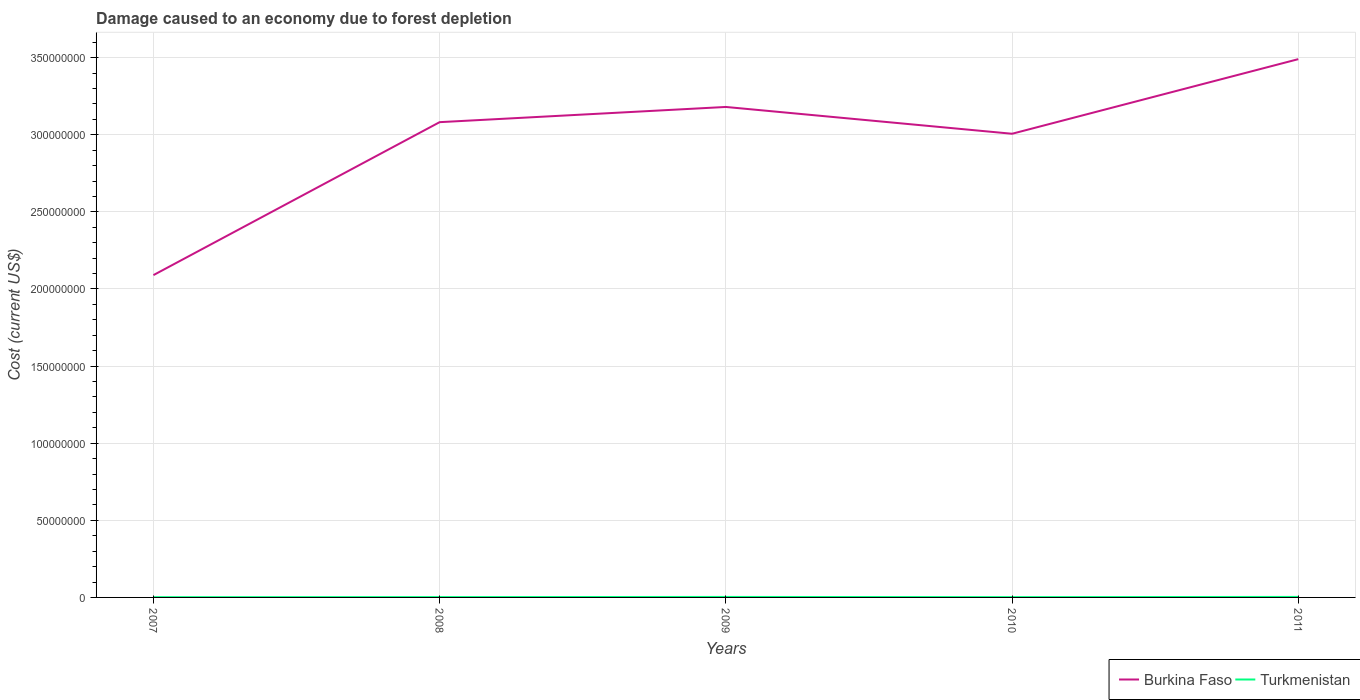Across all years, what is the maximum cost of damage caused due to forest depletion in Burkina Faso?
Your response must be concise. 2.09e+08. What is the total cost of damage caused due to forest depletion in Turkmenistan in the graph?
Offer a very short reply. -1.35e+05. What is the difference between the highest and the second highest cost of damage caused due to forest depletion in Turkmenistan?
Provide a succinct answer. 1.66e+05. What is the difference between the highest and the lowest cost of damage caused due to forest depletion in Burkina Faso?
Give a very brief answer. 4. Is the cost of damage caused due to forest depletion in Turkmenistan strictly greater than the cost of damage caused due to forest depletion in Burkina Faso over the years?
Offer a terse response. Yes. How many lines are there?
Keep it short and to the point. 2. What is the difference between two consecutive major ticks on the Y-axis?
Your response must be concise. 5.00e+07. Are the values on the major ticks of Y-axis written in scientific E-notation?
Keep it short and to the point. No. How many legend labels are there?
Offer a very short reply. 2. How are the legend labels stacked?
Keep it short and to the point. Horizontal. What is the title of the graph?
Provide a succinct answer. Damage caused to an economy due to forest depletion. Does "Cayman Islands" appear as one of the legend labels in the graph?
Offer a terse response. No. What is the label or title of the X-axis?
Your answer should be very brief. Years. What is the label or title of the Y-axis?
Ensure brevity in your answer.  Cost (current US$). What is the Cost (current US$) in Burkina Faso in 2007?
Your response must be concise. 2.09e+08. What is the Cost (current US$) of Turkmenistan in 2007?
Give a very brief answer. 1.61e+05. What is the Cost (current US$) in Burkina Faso in 2008?
Make the answer very short. 3.08e+08. What is the Cost (current US$) in Turkmenistan in 2008?
Make the answer very short. 2.20e+05. What is the Cost (current US$) in Burkina Faso in 2009?
Make the answer very short. 3.18e+08. What is the Cost (current US$) in Turkmenistan in 2009?
Ensure brevity in your answer.  3.14e+05. What is the Cost (current US$) in Burkina Faso in 2010?
Your answer should be compact. 3.01e+08. What is the Cost (current US$) in Turkmenistan in 2010?
Provide a short and direct response. 1.93e+05. What is the Cost (current US$) of Burkina Faso in 2011?
Your answer should be very brief. 3.49e+08. What is the Cost (current US$) of Turkmenistan in 2011?
Your answer should be compact. 3.28e+05. Across all years, what is the maximum Cost (current US$) of Burkina Faso?
Give a very brief answer. 3.49e+08. Across all years, what is the maximum Cost (current US$) of Turkmenistan?
Your response must be concise. 3.28e+05. Across all years, what is the minimum Cost (current US$) of Burkina Faso?
Keep it short and to the point. 2.09e+08. Across all years, what is the minimum Cost (current US$) in Turkmenistan?
Provide a short and direct response. 1.61e+05. What is the total Cost (current US$) in Burkina Faso in the graph?
Your answer should be compact. 1.48e+09. What is the total Cost (current US$) in Turkmenistan in the graph?
Give a very brief answer. 1.22e+06. What is the difference between the Cost (current US$) in Burkina Faso in 2007 and that in 2008?
Provide a succinct answer. -9.92e+07. What is the difference between the Cost (current US$) of Turkmenistan in 2007 and that in 2008?
Ensure brevity in your answer.  -5.89e+04. What is the difference between the Cost (current US$) of Burkina Faso in 2007 and that in 2009?
Your answer should be compact. -1.09e+08. What is the difference between the Cost (current US$) in Turkmenistan in 2007 and that in 2009?
Your answer should be very brief. -1.52e+05. What is the difference between the Cost (current US$) in Burkina Faso in 2007 and that in 2010?
Provide a succinct answer. -9.17e+07. What is the difference between the Cost (current US$) in Turkmenistan in 2007 and that in 2010?
Your answer should be very brief. -3.18e+04. What is the difference between the Cost (current US$) of Burkina Faso in 2007 and that in 2011?
Make the answer very short. -1.40e+08. What is the difference between the Cost (current US$) of Turkmenistan in 2007 and that in 2011?
Your answer should be compact. -1.66e+05. What is the difference between the Cost (current US$) in Burkina Faso in 2008 and that in 2009?
Give a very brief answer. -9.86e+06. What is the difference between the Cost (current US$) of Turkmenistan in 2008 and that in 2009?
Your response must be concise. -9.36e+04. What is the difference between the Cost (current US$) in Burkina Faso in 2008 and that in 2010?
Provide a succinct answer. 7.52e+06. What is the difference between the Cost (current US$) of Turkmenistan in 2008 and that in 2010?
Offer a very short reply. 2.71e+04. What is the difference between the Cost (current US$) in Burkina Faso in 2008 and that in 2011?
Provide a succinct answer. -4.09e+07. What is the difference between the Cost (current US$) in Turkmenistan in 2008 and that in 2011?
Make the answer very short. -1.07e+05. What is the difference between the Cost (current US$) in Burkina Faso in 2009 and that in 2010?
Offer a very short reply. 1.74e+07. What is the difference between the Cost (current US$) of Turkmenistan in 2009 and that in 2010?
Make the answer very short. 1.21e+05. What is the difference between the Cost (current US$) of Burkina Faso in 2009 and that in 2011?
Your response must be concise. -3.10e+07. What is the difference between the Cost (current US$) of Turkmenistan in 2009 and that in 2011?
Offer a terse response. -1.39e+04. What is the difference between the Cost (current US$) of Burkina Faso in 2010 and that in 2011?
Make the answer very short. -4.84e+07. What is the difference between the Cost (current US$) in Turkmenistan in 2010 and that in 2011?
Your answer should be compact. -1.35e+05. What is the difference between the Cost (current US$) in Burkina Faso in 2007 and the Cost (current US$) in Turkmenistan in 2008?
Give a very brief answer. 2.09e+08. What is the difference between the Cost (current US$) in Burkina Faso in 2007 and the Cost (current US$) in Turkmenistan in 2009?
Provide a short and direct response. 2.09e+08. What is the difference between the Cost (current US$) of Burkina Faso in 2007 and the Cost (current US$) of Turkmenistan in 2010?
Provide a short and direct response. 2.09e+08. What is the difference between the Cost (current US$) of Burkina Faso in 2007 and the Cost (current US$) of Turkmenistan in 2011?
Give a very brief answer. 2.09e+08. What is the difference between the Cost (current US$) of Burkina Faso in 2008 and the Cost (current US$) of Turkmenistan in 2009?
Keep it short and to the point. 3.08e+08. What is the difference between the Cost (current US$) in Burkina Faso in 2008 and the Cost (current US$) in Turkmenistan in 2010?
Ensure brevity in your answer.  3.08e+08. What is the difference between the Cost (current US$) in Burkina Faso in 2008 and the Cost (current US$) in Turkmenistan in 2011?
Keep it short and to the point. 3.08e+08. What is the difference between the Cost (current US$) of Burkina Faso in 2009 and the Cost (current US$) of Turkmenistan in 2010?
Make the answer very short. 3.18e+08. What is the difference between the Cost (current US$) of Burkina Faso in 2009 and the Cost (current US$) of Turkmenistan in 2011?
Make the answer very short. 3.18e+08. What is the difference between the Cost (current US$) in Burkina Faso in 2010 and the Cost (current US$) in Turkmenistan in 2011?
Offer a very short reply. 3.00e+08. What is the average Cost (current US$) in Burkina Faso per year?
Your answer should be compact. 2.97e+08. What is the average Cost (current US$) of Turkmenistan per year?
Give a very brief answer. 2.43e+05. In the year 2007, what is the difference between the Cost (current US$) of Burkina Faso and Cost (current US$) of Turkmenistan?
Your answer should be compact. 2.09e+08. In the year 2008, what is the difference between the Cost (current US$) of Burkina Faso and Cost (current US$) of Turkmenistan?
Your response must be concise. 3.08e+08. In the year 2009, what is the difference between the Cost (current US$) in Burkina Faso and Cost (current US$) in Turkmenistan?
Keep it short and to the point. 3.18e+08. In the year 2010, what is the difference between the Cost (current US$) of Burkina Faso and Cost (current US$) of Turkmenistan?
Provide a short and direct response. 3.00e+08. In the year 2011, what is the difference between the Cost (current US$) of Burkina Faso and Cost (current US$) of Turkmenistan?
Keep it short and to the point. 3.49e+08. What is the ratio of the Cost (current US$) in Burkina Faso in 2007 to that in 2008?
Give a very brief answer. 0.68. What is the ratio of the Cost (current US$) of Turkmenistan in 2007 to that in 2008?
Offer a very short reply. 0.73. What is the ratio of the Cost (current US$) of Burkina Faso in 2007 to that in 2009?
Keep it short and to the point. 0.66. What is the ratio of the Cost (current US$) of Turkmenistan in 2007 to that in 2009?
Give a very brief answer. 0.51. What is the ratio of the Cost (current US$) in Burkina Faso in 2007 to that in 2010?
Your answer should be compact. 0.7. What is the ratio of the Cost (current US$) in Turkmenistan in 2007 to that in 2010?
Your answer should be very brief. 0.84. What is the ratio of the Cost (current US$) of Burkina Faso in 2007 to that in 2011?
Your answer should be compact. 0.6. What is the ratio of the Cost (current US$) in Turkmenistan in 2007 to that in 2011?
Give a very brief answer. 0.49. What is the ratio of the Cost (current US$) in Turkmenistan in 2008 to that in 2009?
Provide a short and direct response. 0.7. What is the ratio of the Cost (current US$) of Burkina Faso in 2008 to that in 2010?
Offer a very short reply. 1.02. What is the ratio of the Cost (current US$) of Turkmenistan in 2008 to that in 2010?
Give a very brief answer. 1.14. What is the ratio of the Cost (current US$) in Burkina Faso in 2008 to that in 2011?
Give a very brief answer. 0.88. What is the ratio of the Cost (current US$) of Turkmenistan in 2008 to that in 2011?
Give a very brief answer. 0.67. What is the ratio of the Cost (current US$) of Burkina Faso in 2009 to that in 2010?
Keep it short and to the point. 1.06. What is the ratio of the Cost (current US$) of Turkmenistan in 2009 to that in 2010?
Make the answer very short. 1.62. What is the ratio of the Cost (current US$) of Burkina Faso in 2009 to that in 2011?
Provide a succinct answer. 0.91. What is the ratio of the Cost (current US$) in Turkmenistan in 2009 to that in 2011?
Offer a very short reply. 0.96. What is the ratio of the Cost (current US$) in Burkina Faso in 2010 to that in 2011?
Keep it short and to the point. 0.86. What is the ratio of the Cost (current US$) in Turkmenistan in 2010 to that in 2011?
Your answer should be very brief. 0.59. What is the difference between the highest and the second highest Cost (current US$) of Burkina Faso?
Provide a succinct answer. 3.10e+07. What is the difference between the highest and the second highest Cost (current US$) of Turkmenistan?
Your answer should be compact. 1.39e+04. What is the difference between the highest and the lowest Cost (current US$) of Burkina Faso?
Offer a terse response. 1.40e+08. What is the difference between the highest and the lowest Cost (current US$) of Turkmenistan?
Give a very brief answer. 1.66e+05. 